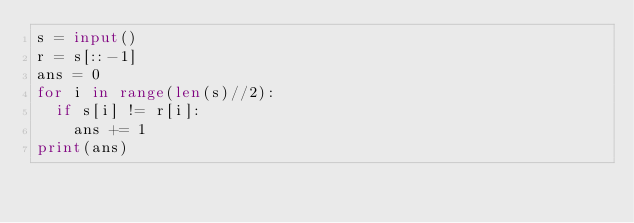<code> <loc_0><loc_0><loc_500><loc_500><_Python_>s = input()
r = s[::-1]
ans = 0
for i in range(len(s)//2):
  if s[i] != r[i]:
    ans += 1
print(ans)</code> 